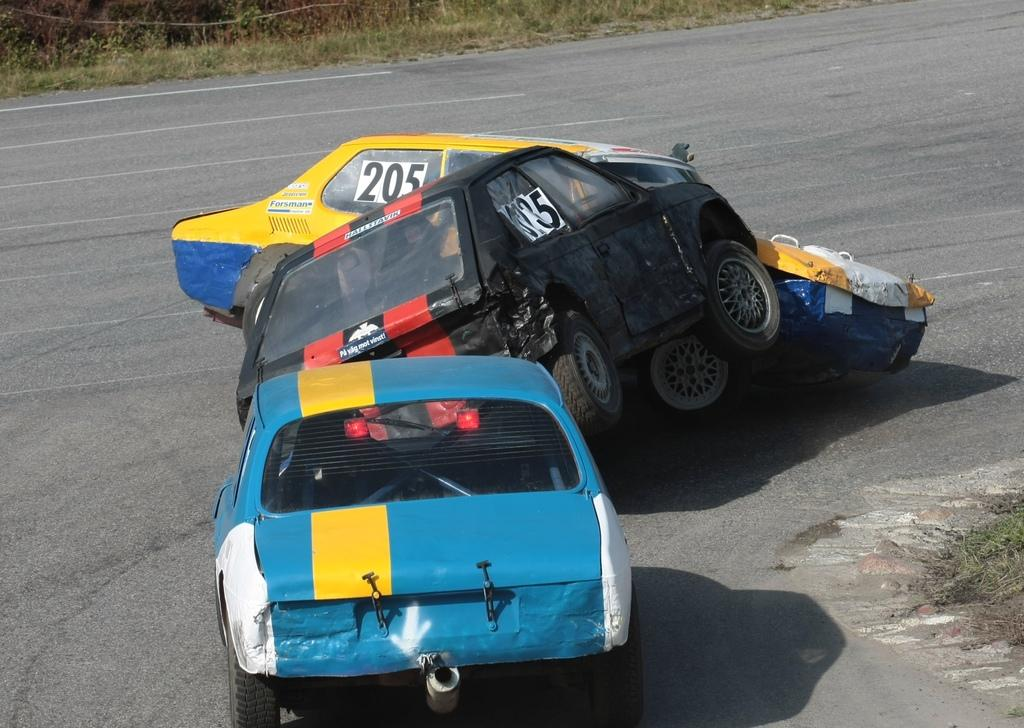How many cars are involved in the collision in the image? There are three cars in the image. What is happening to the cars in the image? The cars are crashing into one another. What is the setting of the image? There is a road in the image. What can be seen in the background of the image? There is grass in the background of the image. What type of error message is displayed on the school's horn in the image? There is no school or horn present in the image; it features a collision involving three cars on a road with grass in the background. 